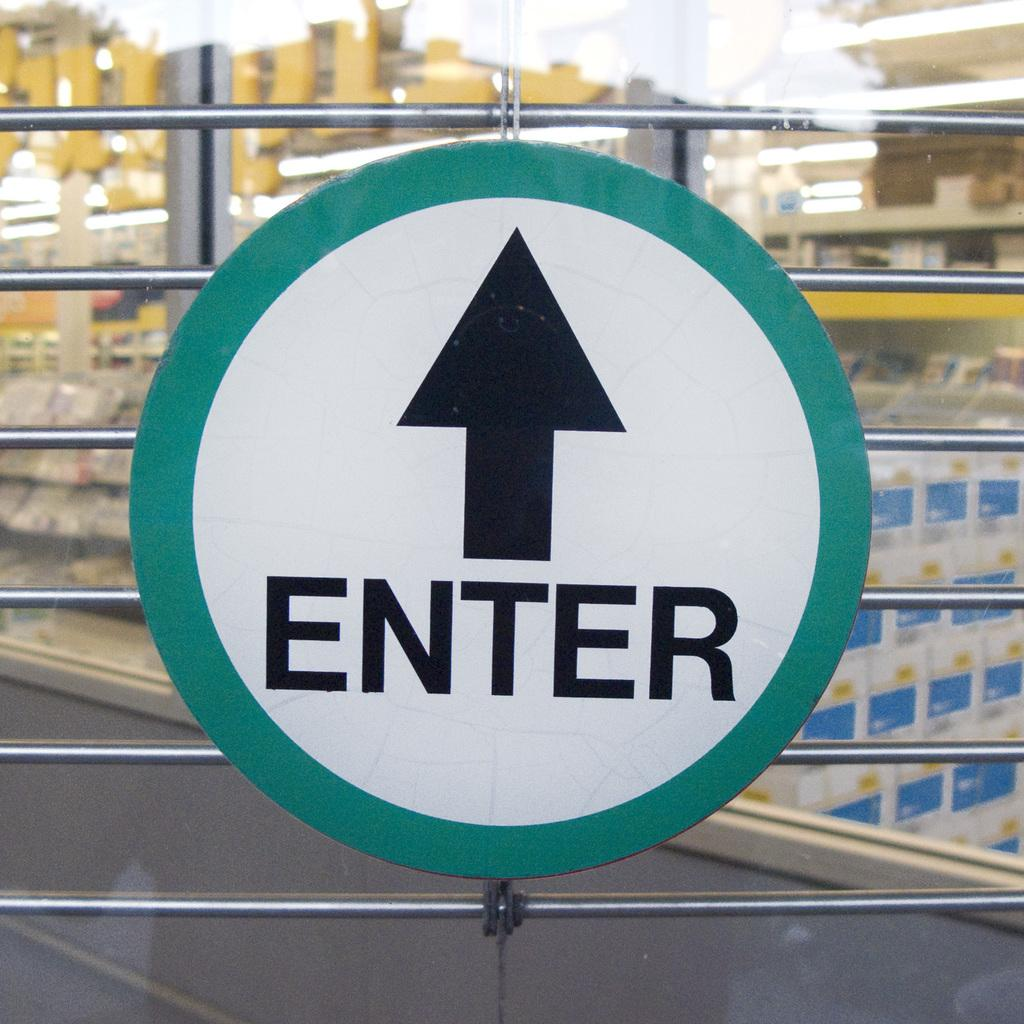<image>
Relay a brief, clear account of the picture shown. The green and white ENTER sign has an arrow pointing up.. 